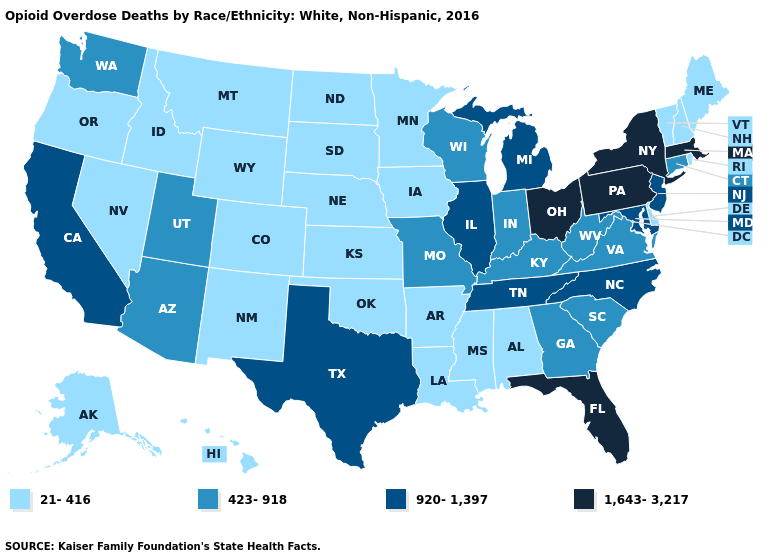Does Florida have the highest value in the South?
Answer briefly. Yes. Among the states that border Illinois , which have the lowest value?
Quick response, please. Iowa. What is the value of North Carolina?
Answer briefly. 920-1,397. What is the value of Utah?
Write a very short answer. 423-918. What is the lowest value in the USA?
Write a very short answer. 21-416. Which states have the lowest value in the West?
Write a very short answer. Alaska, Colorado, Hawaii, Idaho, Montana, Nevada, New Mexico, Oregon, Wyoming. Name the states that have a value in the range 21-416?
Concise answer only. Alabama, Alaska, Arkansas, Colorado, Delaware, Hawaii, Idaho, Iowa, Kansas, Louisiana, Maine, Minnesota, Mississippi, Montana, Nebraska, Nevada, New Hampshire, New Mexico, North Dakota, Oklahoma, Oregon, Rhode Island, South Dakota, Vermont, Wyoming. Does Ohio have the highest value in the USA?
Be succinct. Yes. What is the value of West Virginia?
Keep it brief. 423-918. Which states hav the highest value in the West?
Quick response, please. California. What is the lowest value in the USA?
Answer briefly. 21-416. What is the value of Oklahoma?
Keep it brief. 21-416. Name the states that have a value in the range 920-1,397?
Be succinct. California, Illinois, Maryland, Michigan, New Jersey, North Carolina, Tennessee, Texas. What is the value of Iowa?
Answer briefly. 21-416. What is the value of Wyoming?
Be succinct. 21-416. 